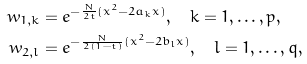<formula> <loc_0><loc_0><loc_500><loc_500>w _ { 1 , k } & = e ^ { - \frac { N } { 2 t } ( x ^ { 2 } - 2 a _ { k } x ) } , \quad k = 1 , \dots , p , \\ w _ { 2 , l } & = e ^ { - \frac { N } { 2 ( 1 - t ) } ( x ^ { 2 } - 2 b _ { l } x ) } , \quad l = 1 , \dots , q ,</formula> 